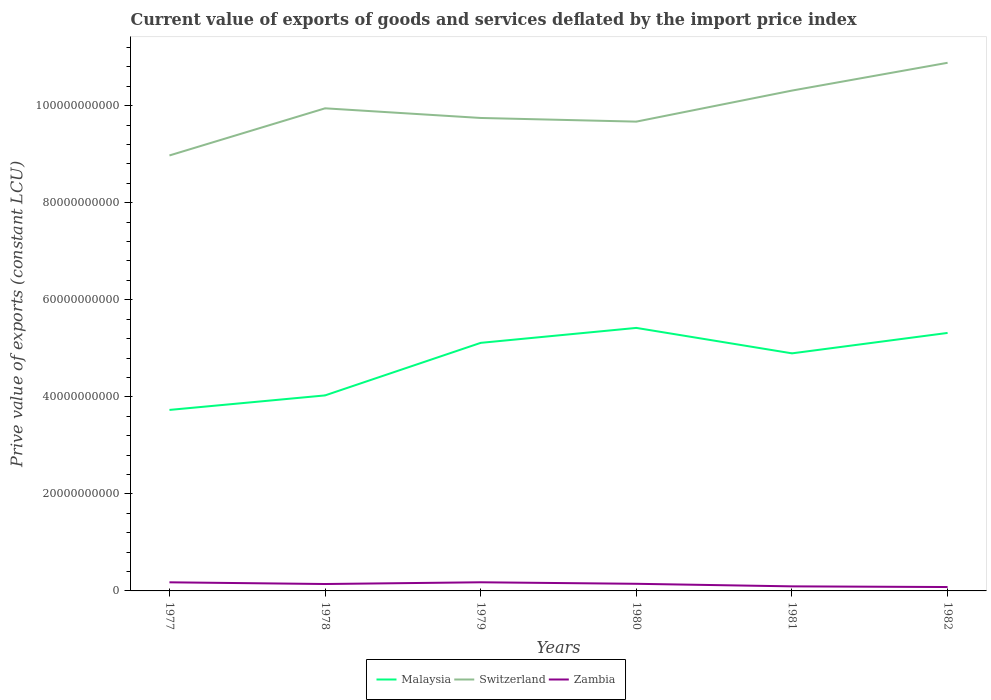Across all years, what is the maximum prive value of exports in Malaysia?
Offer a terse response. 3.73e+1. What is the total prive value of exports in Switzerland in the graph?
Your answer should be very brief. -9.72e+09. What is the difference between the highest and the second highest prive value of exports in Zambia?
Provide a short and direct response. 9.79e+08. What is the difference between the highest and the lowest prive value of exports in Zambia?
Keep it short and to the point. 4. How many lines are there?
Your response must be concise. 3. How many years are there in the graph?
Provide a short and direct response. 6. Are the values on the major ticks of Y-axis written in scientific E-notation?
Your answer should be compact. No. Does the graph contain grids?
Give a very brief answer. No. Where does the legend appear in the graph?
Offer a terse response. Bottom center. How many legend labels are there?
Make the answer very short. 3. How are the legend labels stacked?
Provide a succinct answer. Horizontal. What is the title of the graph?
Offer a terse response. Current value of exports of goods and services deflated by the import price index. What is the label or title of the Y-axis?
Keep it short and to the point. Prive value of exports (constant LCU). What is the Prive value of exports (constant LCU) in Malaysia in 1977?
Keep it short and to the point. 3.73e+1. What is the Prive value of exports (constant LCU) of Switzerland in 1977?
Offer a very short reply. 8.97e+1. What is the Prive value of exports (constant LCU) of Zambia in 1977?
Ensure brevity in your answer.  1.77e+09. What is the Prive value of exports (constant LCU) in Malaysia in 1978?
Offer a very short reply. 4.03e+1. What is the Prive value of exports (constant LCU) of Switzerland in 1978?
Give a very brief answer. 9.95e+1. What is the Prive value of exports (constant LCU) in Zambia in 1978?
Your response must be concise. 1.42e+09. What is the Prive value of exports (constant LCU) in Malaysia in 1979?
Provide a succinct answer. 5.11e+1. What is the Prive value of exports (constant LCU) in Switzerland in 1979?
Make the answer very short. 9.75e+1. What is the Prive value of exports (constant LCU) of Zambia in 1979?
Make the answer very short. 1.78e+09. What is the Prive value of exports (constant LCU) in Malaysia in 1980?
Ensure brevity in your answer.  5.42e+1. What is the Prive value of exports (constant LCU) of Switzerland in 1980?
Your answer should be compact. 9.67e+1. What is the Prive value of exports (constant LCU) of Zambia in 1980?
Offer a very short reply. 1.47e+09. What is the Prive value of exports (constant LCU) of Malaysia in 1981?
Your answer should be very brief. 4.90e+1. What is the Prive value of exports (constant LCU) in Switzerland in 1981?
Offer a very short reply. 1.03e+11. What is the Prive value of exports (constant LCU) in Zambia in 1981?
Make the answer very short. 9.42e+08. What is the Prive value of exports (constant LCU) of Malaysia in 1982?
Keep it short and to the point. 5.32e+1. What is the Prive value of exports (constant LCU) of Switzerland in 1982?
Offer a very short reply. 1.09e+11. What is the Prive value of exports (constant LCU) of Zambia in 1982?
Ensure brevity in your answer.  8.01e+08. Across all years, what is the maximum Prive value of exports (constant LCU) of Malaysia?
Provide a short and direct response. 5.42e+1. Across all years, what is the maximum Prive value of exports (constant LCU) in Switzerland?
Keep it short and to the point. 1.09e+11. Across all years, what is the maximum Prive value of exports (constant LCU) in Zambia?
Your answer should be very brief. 1.78e+09. Across all years, what is the minimum Prive value of exports (constant LCU) of Malaysia?
Your response must be concise. 3.73e+1. Across all years, what is the minimum Prive value of exports (constant LCU) of Switzerland?
Provide a succinct answer. 8.97e+1. Across all years, what is the minimum Prive value of exports (constant LCU) in Zambia?
Provide a short and direct response. 8.01e+08. What is the total Prive value of exports (constant LCU) of Malaysia in the graph?
Provide a short and direct response. 2.85e+11. What is the total Prive value of exports (constant LCU) of Switzerland in the graph?
Provide a short and direct response. 5.95e+11. What is the total Prive value of exports (constant LCU) in Zambia in the graph?
Offer a terse response. 8.19e+09. What is the difference between the Prive value of exports (constant LCU) in Malaysia in 1977 and that in 1978?
Your response must be concise. -2.99e+09. What is the difference between the Prive value of exports (constant LCU) in Switzerland in 1977 and that in 1978?
Offer a terse response. -9.72e+09. What is the difference between the Prive value of exports (constant LCU) of Zambia in 1977 and that in 1978?
Offer a very short reply. 3.51e+08. What is the difference between the Prive value of exports (constant LCU) in Malaysia in 1977 and that in 1979?
Your answer should be compact. -1.38e+1. What is the difference between the Prive value of exports (constant LCU) in Switzerland in 1977 and that in 1979?
Your answer should be very brief. -7.73e+09. What is the difference between the Prive value of exports (constant LCU) of Zambia in 1977 and that in 1979?
Offer a very short reply. -6.93e+06. What is the difference between the Prive value of exports (constant LCU) in Malaysia in 1977 and that in 1980?
Offer a terse response. -1.69e+1. What is the difference between the Prive value of exports (constant LCU) in Switzerland in 1977 and that in 1980?
Ensure brevity in your answer.  -6.97e+09. What is the difference between the Prive value of exports (constant LCU) of Zambia in 1977 and that in 1980?
Offer a terse response. 3.04e+08. What is the difference between the Prive value of exports (constant LCU) of Malaysia in 1977 and that in 1981?
Keep it short and to the point. -1.17e+1. What is the difference between the Prive value of exports (constant LCU) in Switzerland in 1977 and that in 1981?
Your answer should be very brief. -1.34e+1. What is the difference between the Prive value of exports (constant LCU) of Zambia in 1977 and that in 1981?
Make the answer very short. 8.31e+08. What is the difference between the Prive value of exports (constant LCU) of Malaysia in 1977 and that in 1982?
Offer a very short reply. -1.59e+1. What is the difference between the Prive value of exports (constant LCU) of Switzerland in 1977 and that in 1982?
Your response must be concise. -1.91e+1. What is the difference between the Prive value of exports (constant LCU) of Zambia in 1977 and that in 1982?
Ensure brevity in your answer.  9.72e+08. What is the difference between the Prive value of exports (constant LCU) of Malaysia in 1978 and that in 1979?
Give a very brief answer. -1.08e+1. What is the difference between the Prive value of exports (constant LCU) in Switzerland in 1978 and that in 1979?
Make the answer very short. 1.99e+09. What is the difference between the Prive value of exports (constant LCU) of Zambia in 1978 and that in 1979?
Offer a terse response. -3.58e+08. What is the difference between the Prive value of exports (constant LCU) in Malaysia in 1978 and that in 1980?
Offer a very short reply. -1.39e+1. What is the difference between the Prive value of exports (constant LCU) in Switzerland in 1978 and that in 1980?
Offer a terse response. 2.74e+09. What is the difference between the Prive value of exports (constant LCU) of Zambia in 1978 and that in 1980?
Provide a short and direct response. -4.68e+07. What is the difference between the Prive value of exports (constant LCU) in Malaysia in 1978 and that in 1981?
Your response must be concise. -8.67e+09. What is the difference between the Prive value of exports (constant LCU) in Switzerland in 1978 and that in 1981?
Make the answer very short. -3.66e+09. What is the difference between the Prive value of exports (constant LCU) of Zambia in 1978 and that in 1981?
Your response must be concise. 4.81e+08. What is the difference between the Prive value of exports (constant LCU) of Malaysia in 1978 and that in 1982?
Provide a succinct answer. -1.29e+1. What is the difference between the Prive value of exports (constant LCU) of Switzerland in 1978 and that in 1982?
Provide a succinct answer. -9.38e+09. What is the difference between the Prive value of exports (constant LCU) of Zambia in 1978 and that in 1982?
Provide a succinct answer. 6.21e+08. What is the difference between the Prive value of exports (constant LCU) of Malaysia in 1979 and that in 1980?
Provide a short and direct response. -3.08e+09. What is the difference between the Prive value of exports (constant LCU) in Switzerland in 1979 and that in 1980?
Provide a short and direct response. 7.52e+08. What is the difference between the Prive value of exports (constant LCU) of Zambia in 1979 and that in 1980?
Make the answer very short. 3.11e+08. What is the difference between the Prive value of exports (constant LCU) of Malaysia in 1979 and that in 1981?
Ensure brevity in your answer.  2.16e+09. What is the difference between the Prive value of exports (constant LCU) of Switzerland in 1979 and that in 1981?
Your answer should be compact. -5.65e+09. What is the difference between the Prive value of exports (constant LCU) of Zambia in 1979 and that in 1981?
Provide a succinct answer. 8.38e+08. What is the difference between the Prive value of exports (constant LCU) in Malaysia in 1979 and that in 1982?
Keep it short and to the point. -2.05e+09. What is the difference between the Prive value of exports (constant LCU) of Switzerland in 1979 and that in 1982?
Provide a succinct answer. -1.14e+1. What is the difference between the Prive value of exports (constant LCU) in Zambia in 1979 and that in 1982?
Give a very brief answer. 9.79e+08. What is the difference between the Prive value of exports (constant LCU) in Malaysia in 1980 and that in 1981?
Provide a succinct answer. 5.24e+09. What is the difference between the Prive value of exports (constant LCU) of Switzerland in 1980 and that in 1981?
Your response must be concise. -6.40e+09. What is the difference between the Prive value of exports (constant LCU) of Zambia in 1980 and that in 1981?
Make the answer very short. 5.27e+08. What is the difference between the Prive value of exports (constant LCU) of Malaysia in 1980 and that in 1982?
Offer a terse response. 1.03e+09. What is the difference between the Prive value of exports (constant LCU) in Switzerland in 1980 and that in 1982?
Offer a terse response. -1.21e+1. What is the difference between the Prive value of exports (constant LCU) in Zambia in 1980 and that in 1982?
Ensure brevity in your answer.  6.68e+08. What is the difference between the Prive value of exports (constant LCU) in Malaysia in 1981 and that in 1982?
Your answer should be compact. -4.21e+09. What is the difference between the Prive value of exports (constant LCU) in Switzerland in 1981 and that in 1982?
Your answer should be very brief. -5.73e+09. What is the difference between the Prive value of exports (constant LCU) of Zambia in 1981 and that in 1982?
Offer a very short reply. 1.40e+08. What is the difference between the Prive value of exports (constant LCU) of Malaysia in 1977 and the Prive value of exports (constant LCU) of Switzerland in 1978?
Make the answer very short. -6.22e+1. What is the difference between the Prive value of exports (constant LCU) in Malaysia in 1977 and the Prive value of exports (constant LCU) in Zambia in 1978?
Your answer should be very brief. 3.59e+1. What is the difference between the Prive value of exports (constant LCU) of Switzerland in 1977 and the Prive value of exports (constant LCU) of Zambia in 1978?
Your answer should be compact. 8.83e+1. What is the difference between the Prive value of exports (constant LCU) of Malaysia in 1977 and the Prive value of exports (constant LCU) of Switzerland in 1979?
Keep it short and to the point. -6.02e+1. What is the difference between the Prive value of exports (constant LCU) in Malaysia in 1977 and the Prive value of exports (constant LCU) in Zambia in 1979?
Your answer should be compact. 3.55e+1. What is the difference between the Prive value of exports (constant LCU) of Switzerland in 1977 and the Prive value of exports (constant LCU) of Zambia in 1979?
Keep it short and to the point. 8.80e+1. What is the difference between the Prive value of exports (constant LCU) of Malaysia in 1977 and the Prive value of exports (constant LCU) of Switzerland in 1980?
Make the answer very short. -5.94e+1. What is the difference between the Prive value of exports (constant LCU) of Malaysia in 1977 and the Prive value of exports (constant LCU) of Zambia in 1980?
Give a very brief answer. 3.58e+1. What is the difference between the Prive value of exports (constant LCU) in Switzerland in 1977 and the Prive value of exports (constant LCU) in Zambia in 1980?
Provide a succinct answer. 8.83e+1. What is the difference between the Prive value of exports (constant LCU) in Malaysia in 1977 and the Prive value of exports (constant LCU) in Switzerland in 1981?
Give a very brief answer. -6.58e+1. What is the difference between the Prive value of exports (constant LCU) in Malaysia in 1977 and the Prive value of exports (constant LCU) in Zambia in 1981?
Make the answer very short. 3.64e+1. What is the difference between the Prive value of exports (constant LCU) of Switzerland in 1977 and the Prive value of exports (constant LCU) of Zambia in 1981?
Give a very brief answer. 8.88e+1. What is the difference between the Prive value of exports (constant LCU) in Malaysia in 1977 and the Prive value of exports (constant LCU) in Switzerland in 1982?
Make the answer very short. -7.15e+1. What is the difference between the Prive value of exports (constant LCU) of Malaysia in 1977 and the Prive value of exports (constant LCU) of Zambia in 1982?
Provide a short and direct response. 3.65e+1. What is the difference between the Prive value of exports (constant LCU) in Switzerland in 1977 and the Prive value of exports (constant LCU) in Zambia in 1982?
Your answer should be very brief. 8.89e+1. What is the difference between the Prive value of exports (constant LCU) in Malaysia in 1978 and the Prive value of exports (constant LCU) in Switzerland in 1979?
Offer a very short reply. -5.72e+1. What is the difference between the Prive value of exports (constant LCU) in Malaysia in 1978 and the Prive value of exports (constant LCU) in Zambia in 1979?
Offer a terse response. 3.85e+1. What is the difference between the Prive value of exports (constant LCU) of Switzerland in 1978 and the Prive value of exports (constant LCU) of Zambia in 1979?
Offer a very short reply. 9.77e+1. What is the difference between the Prive value of exports (constant LCU) of Malaysia in 1978 and the Prive value of exports (constant LCU) of Switzerland in 1980?
Offer a terse response. -5.64e+1. What is the difference between the Prive value of exports (constant LCU) in Malaysia in 1978 and the Prive value of exports (constant LCU) in Zambia in 1980?
Keep it short and to the point. 3.88e+1. What is the difference between the Prive value of exports (constant LCU) of Switzerland in 1978 and the Prive value of exports (constant LCU) of Zambia in 1980?
Your response must be concise. 9.80e+1. What is the difference between the Prive value of exports (constant LCU) in Malaysia in 1978 and the Prive value of exports (constant LCU) in Switzerland in 1981?
Your answer should be compact. -6.28e+1. What is the difference between the Prive value of exports (constant LCU) in Malaysia in 1978 and the Prive value of exports (constant LCU) in Zambia in 1981?
Give a very brief answer. 3.94e+1. What is the difference between the Prive value of exports (constant LCU) in Switzerland in 1978 and the Prive value of exports (constant LCU) in Zambia in 1981?
Give a very brief answer. 9.85e+1. What is the difference between the Prive value of exports (constant LCU) of Malaysia in 1978 and the Prive value of exports (constant LCU) of Switzerland in 1982?
Ensure brevity in your answer.  -6.85e+1. What is the difference between the Prive value of exports (constant LCU) of Malaysia in 1978 and the Prive value of exports (constant LCU) of Zambia in 1982?
Provide a short and direct response. 3.95e+1. What is the difference between the Prive value of exports (constant LCU) in Switzerland in 1978 and the Prive value of exports (constant LCU) in Zambia in 1982?
Your answer should be compact. 9.87e+1. What is the difference between the Prive value of exports (constant LCU) of Malaysia in 1979 and the Prive value of exports (constant LCU) of Switzerland in 1980?
Your answer should be very brief. -4.56e+1. What is the difference between the Prive value of exports (constant LCU) in Malaysia in 1979 and the Prive value of exports (constant LCU) in Zambia in 1980?
Your answer should be very brief. 4.97e+1. What is the difference between the Prive value of exports (constant LCU) of Switzerland in 1979 and the Prive value of exports (constant LCU) of Zambia in 1980?
Ensure brevity in your answer.  9.60e+1. What is the difference between the Prive value of exports (constant LCU) of Malaysia in 1979 and the Prive value of exports (constant LCU) of Switzerland in 1981?
Make the answer very short. -5.20e+1. What is the difference between the Prive value of exports (constant LCU) in Malaysia in 1979 and the Prive value of exports (constant LCU) in Zambia in 1981?
Your answer should be very brief. 5.02e+1. What is the difference between the Prive value of exports (constant LCU) in Switzerland in 1979 and the Prive value of exports (constant LCU) in Zambia in 1981?
Your answer should be very brief. 9.65e+1. What is the difference between the Prive value of exports (constant LCU) in Malaysia in 1979 and the Prive value of exports (constant LCU) in Switzerland in 1982?
Make the answer very short. -5.77e+1. What is the difference between the Prive value of exports (constant LCU) in Malaysia in 1979 and the Prive value of exports (constant LCU) in Zambia in 1982?
Ensure brevity in your answer.  5.03e+1. What is the difference between the Prive value of exports (constant LCU) of Switzerland in 1979 and the Prive value of exports (constant LCU) of Zambia in 1982?
Offer a terse response. 9.67e+1. What is the difference between the Prive value of exports (constant LCU) of Malaysia in 1980 and the Prive value of exports (constant LCU) of Switzerland in 1981?
Give a very brief answer. -4.89e+1. What is the difference between the Prive value of exports (constant LCU) of Malaysia in 1980 and the Prive value of exports (constant LCU) of Zambia in 1981?
Keep it short and to the point. 5.33e+1. What is the difference between the Prive value of exports (constant LCU) of Switzerland in 1980 and the Prive value of exports (constant LCU) of Zambia in 1981?
Offer a terse response. 9.58e+1. What is the difference between the Prive value of exports (constant LCU) in Malaysia in 1980 and the Prive value of exports (constant LCU) in Switzerland in 1982?
Provide a short and direct response. -5.46e+1. What is the difference between the Prive value of exports (constant LCU) of Malaysia in 1980 and the Prive value of exports (constant LCU) of Zambia in 1982?
Your answer should be very brief. 5.34e+1. What is the difference between the Prive value of exports (constant LCU) of Switzerland in 1980 and the Prive value of exports (constant LCU) of Zambia in 1982?
Your answer should be very brief. 9.59e+1. What is the difference between the Prive value of exports (constant LCU) of Malaysia in 1981 and the Prive value of exports (constant LCU) of Switzerland in 1982?
Your answer should be compact. -5.99e+1. What is the difference between the Prive value of exports (constant LCU) of Malaysia in 1981 and the Prive value of exports (constant LCU) of Zambia in 1982?
Your response must be concise. 4.82e+1. What is the difference between the Prive value of exports (constant LCU) in Switzerland in 1981 and the Prive value of exports (constant LCU) in Zambia in 1982?
Give a very brief answer. 1.02e+11. What is the average Prive value of exports (constant LCU) of Malaysia per year?
Offer a very short reply. 4.75e+1. What is the average Prive value of exports (constant LCU) in Switzerland per year?
Offer a terse response. 9.92e+1. What is the average Prive value of exports (constant LCU) in Zambia per year?
Offer a terse response. 1.36e+09. In the year 1977, what is the difference between the Prive value of exports (constant LCU) of Malaysia and Prive value of exports (constant LCU) of Switzerland?
Keep it short and to the point. -5.24e+1. In the year 1977, what is the difference between the Prive value of exports (constant LCU) in Malaysia and Prive value of exports (constant LCU) in Zambia?
Ensure brevity in your answer.  3.55e+1. In the year 1977, what is the difference between the Prive value of exports (constant LCU) of Switzerland and Prive value of exports (constant LCU) of Zambia?
Your answer should be very brief. 8.80e+1. In the year 1978, what is the difference between the Prive value of exports (constant LCU) of Malaysia and Prive value of exports (constant LCU) of Switzerland?
Ensure brevity in your answer.  -5.92e+1. In the year 1978, what is the difference between the Prive value of exports (constant LCU) in Malaysia and Prive value of exports (constant LCU) in Zambia?
Provide a short and direct response. 3.89e+1. In the year 1978, what is the difference between the Prive value of exports (constant LCU) in Switzerland and Prive value of exports (constant LCU) in Zambia?
Give a very brief answer. 9.80e+1. In the year 1979, what is the difference between the Prive value of exports (constant LCU) in Malaysia and Prive value of exports (constant LCU) in Switzerland?
Offer a terse response. -4.63e+1. In the year 1979, what is the difference between the Prive value of exports (constant LCU) of Malaysia and Prive value of exports (constant LCU) of Zambia?
Provide a succinct answer. 4.93e+1. In the year 1979, what is the difference between the Prive value of exports (constant LCU) in Switzerland and Prive value of exports (constant LCU) in Zambia?
Offer a terse response. 9.57e+1. In the year 1980, what is the difference between the Prive value of exports (constant LCU) in Malaysia and Prive value of exports (constant LCU) in Switzerland?
Your answer should be compact. -4.25e+1. In the year 1980, what is the difference between the Prive value of exports (constant LCU) in Malaysia and Prive value of exports (constant LCU) in Zambia?
Offer a terse response. 5.27e+1. In the year 1980, what is the difference between the Prive value of exports (constant LCU) in Switzerland and Prive value of exports (constant LCU) in Zambia?
Offer a terse response. 9.52e+1. In the year 1981, what is the difference between the Prive value of exports (constant LCU) in Malaysia and Prive value of exports (constant LCU) in Switzerland?
Keep it short and to the point. -5.42e+1. In the year 1981, what is the difference between the Prive value of exports (constant LCU) in Malaysia and Prive value of exports (constant LCU) in Zambia?
Keep it short and to the point. 4.80e+1. In the year 1981, what is the difference between the Prive value of exports (constant LCU) in Switzerland and Prive value of exports (constant LCU) in Zambia?
Make the answer very short. 1.02e+11. In the year 1982, what is the difference between the Prive value of exports (constant LCU) in Malaysia and Prive value of exports (constant LCU) in Switzerland?
Keep it short and to the point. -5.57e+1. In the year 1982, what is the difference between the Prive value of exports (constant LCU) of Malaysia and Prive value of exports (constant LCU) of Zambia?
Ensure brevity in your answer.  5.24e+1. In the year 1982, what is the difference between the Prive value of exports (constant LCU) in Switzerland and Prive value of exports (constant LCU) in Zambia?
Provide a succinct answer. 1.08e+11. What is the ratio of the Prive value of exports (constant LCU) in Malaysia in 1977 to that in 1978?
Offer a terse response. 0.93. What is the ratio of the Prive value of exports (constant LCU) of Switzerland in 1977 to that in 1978?
Provide a short and direct response. 0.9. What is the ratio of the Prive value of exports (constant LCU) in Zambia in 1977 to that in 1978?
Offer a very short reply. 1.25. What is the ratio of the Prive value of exports (constant LCU) in Malaysia in 1977 to that in 1979?
Your answer should be compact. 0.73. What is the ratio of the Prive value of exports (constant LCU) of Switzerland in 1977 to that in 1979?
Your answer should be very brief. 0.92. What is the ratio of the Prive value of exports (constant LCU) of Zambia in 1977 to that in 1979?
Ensure brevity in your answer.  1. What is the ratio of the Prive value of exports (constant LCU) of Malaysia in 1977 to that in 1980?
Offer a very short reply. 0.69. What is the ratio of the Prive value of exports (constant LCU) of Switzerland in 1977 to that in 1980?
Ensure brevity in your answer.  0.93. What is the ratio of the Prive value of exports (constant LCU) in Zambia in 1977 to that in 1980?
Make the answer very short. 1.21. What is the ratio of the Prive value of exports (constant LCU) of Malaysia in 1977 to that in 1981?
Your answer should be compact. 0.76. What is the ratio of the Prive value of exports (constant LCU) in Switzerland in 1977 to that in 1981?
Give a very brief answer. 0.87. What is the ratio of the Prive value of exports (constant LCU) of Zambia in 1977 to that in 1981?
Your answer should be very brief. 1.88. What is the ratio of the Prive value of exports (constant LCU) of Malaysia in 1977 to that in 1982?
Offer a terse response. 0.7. What is the ratio of the Prive value of exports (constant LCU) of Switzerland in 1977 to that in 1982?
Your answer should be compact. 0.82. What is the ratio of the Prive value of exports (constant LCU) of Zambia in 1977 to that in 1982?
Provide a short and direct response. 2.21. What is the ratio of the Prive value of exports (constant LCU) in Malaysia in 1978 to that in 1979?
Make the answer very short. 0.79. What is the ratio of the Prive value of exports (constant LCU) in Switzerland in 1978 to that in 1979?
Provide a succinct answer. 1.02. What is the ratio of the Prive value of exports (constant LCU) in Zambia in 1978 to that in 1979?
Give a very brief answer. 0.8. What is the ratio of the Prive value of exports (constant LCU) in Malaysia in 1978 to that in 1980?
Your answer should be compact. 0.74. What is the ratio of the Prive value of exports (constant LCU) of Switzerland in 1978 to that in 1980?
Keep it short and to the point. 1.03. What is the ratio of the Prive value of exports (constant LCU) in Zambia in 1978 to that in 1980?
Offer a terse response. 0.97. What is the ratio of the Prive value of exports (constant LCU) of Malaysia in 1978 to that in 1981?
Your answer should be very brief. 0.82. What is the ratio of the Prive value of exports (constant LCU) of Switzerland in 1978 to that in 1981?
Make the answer very short. 0.96. What is the ratio of the Prive value of exports (constant LCU) in Zambia in 1978 to that in 1981?
Provide a succinct answer. 1.51. What is the ratio of the Prive value of exports (constant LCU) in Malaysia in 1978 to that in 1982?
Offer a very short reply. 0.76. What is the ratio of the Prive value of exports (constant LCU) in Switzerland in 1978 to that in 1982?
Give a very brief answer. 0.91. What is the ratio of the Prive value of exports (constant LCU) of Zambia in 1978 to that in 1982?
Offer a very short reply. 1.78. What is the ratio of the Prive value of exports (constant LCU) in Malaysia in 1979 to that in 1980?
Your response must be concise. 0.94. What is the ratio of the Prive value of exports (constant LCU) of Switzerland in 1979 to that in 1980?
Keep it short and to the point. 1.01. What is the ratio of the Prive value of exports (constant LCU) of Zambia in 1979 to that in 1980?
Your answer should be very brief. 1.21. What is the ratio of the Prive value of exports (constant LCU) of Malaysia in 1979 to that in 1981?
Make the answer very short. 1.04. What is the ratio of the Prive value of exports (constant LCU) of Switzerland in 1979 to that in 1981?
Your answer should be compact. 0.95. What is the ratio of the Prive value of exports (constant LCU) of Zambia in 1979 to that in 1981?
Provide a short and direct response. 1.89. What is the ratio of the Prive value of exports (constant LCU) in Malaysia in 1979 to that in 1982?
Keep it short and to the point. 0.96. What is the ratio of the Prive value of exports (constant LCU) of Switzerland in 1979 to that in 1982?
Your response must be concise. 0.9. What is the ratio of the Prive value of exports (constant LCU) in Zambia in 1979 to that in 1982?
Make the answer very short. 2.22. What is the ratio of the Prive value of exports (constant LCU) of Malaysia in 1980 to that in 1981?
Offer a very short reply. 1.11. What is the ratio of the Prive value of exports (constant LCU) in Switzerland in 1980 to that in 1981?
Give a very brief answer. 0.94. What is the ratio of the Prive value of exports (constant LCU) in Zambia in 1980 to that in 1981?
Give a very brief answer. 1.56. What is the ratio of the Prive value of exports (constant LCU) in Malaysia in 1980 to that in 1982?
Your response must be concise. 1.02. What is the ratio of the Prive value of exports (constant LCU) in Switzerland in 1980 to that in 1982?
Your answer should be very brief. 0.89. What is the ratio of the Prive value of exports (constant LCU) of Zambia in 1980 to that in 1982?
Your answer should be compact. 1.83. What is the ratio of the Prive value of exports (constant LCU) in Malaysia in 1981 to that in 1982?
Offer a terse response. 0.92. What is the ratio of the Prive value of exports (constant LCU) in Switzerland in 1981 to that in 1982?
Keep it short and to the point. 0.95. What is the ratio of the Prive value of exports (constant LCU) of Zambia in 1981 to that in 1982?
Ensure brevity in your answer.  1.18. What is the difference between the highest and the second highest Prive value of exports (constant LCU) in Malaysia?
Offer a very short reply. 1.03e+09. What is the difference between the highest and the second highest Prive value of exports (constant LCU) of Switzerland?
Provide a succinct answer. 5.73e+09. What is the difference between the highest and the second highest Prive value of exports (constant LCU) in Zambia?
Offer a very short reply. 6.93e+06. What is the difference between the highest and the lowest Prive value of exports (constant LCU) of Malaysia?
Your answer should be compact. 1.69e+1. What is the difference between the highest and the lowest Prive value of exports (constant LCU) in Switzerland?
Offer a very short reply. 1.91e+1. What is the difference between the highest and the lowest Prive value of exports (constant LCU) in Zambia?
Offer a terse response. 9.79e+08. 